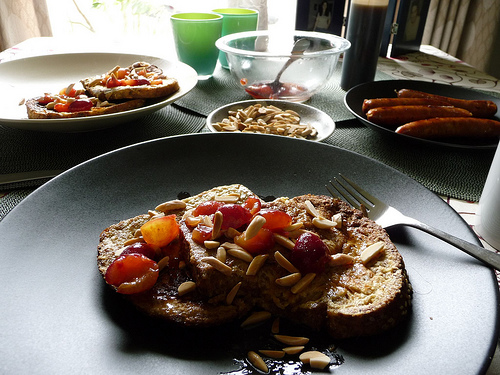<image>
Is there a plate under the food? Yes. The plate is positioned underneath the food, with the food above it in the vertical space. 